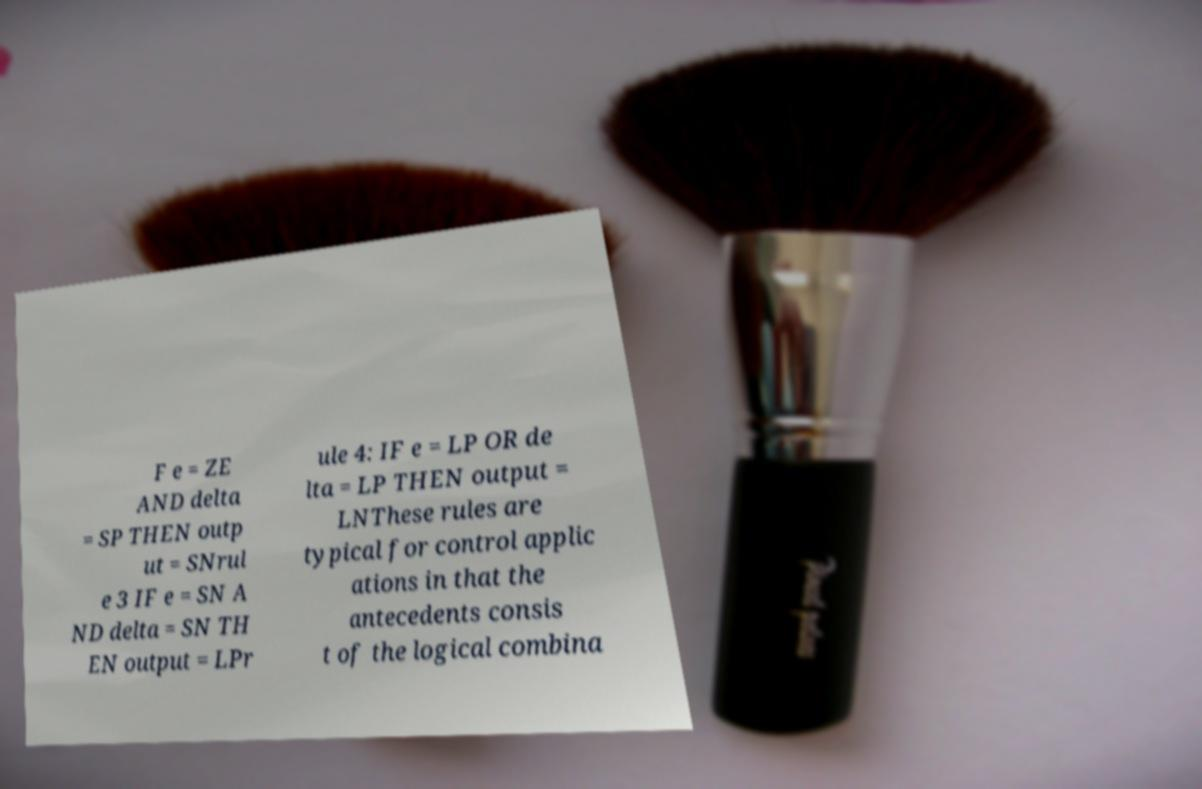Can you accurately transcribe the text from the provided image for me? F e = ZE AND delta = SP THEN outp ut = SNrul e 3 IF e = SN A ND delta = SN TH EN output = LPr ule 4: IF e = LP OR de lta = LP THEN output = LNThese rules are typical for control applic ations in that the antecedents consis t of the logical combina 